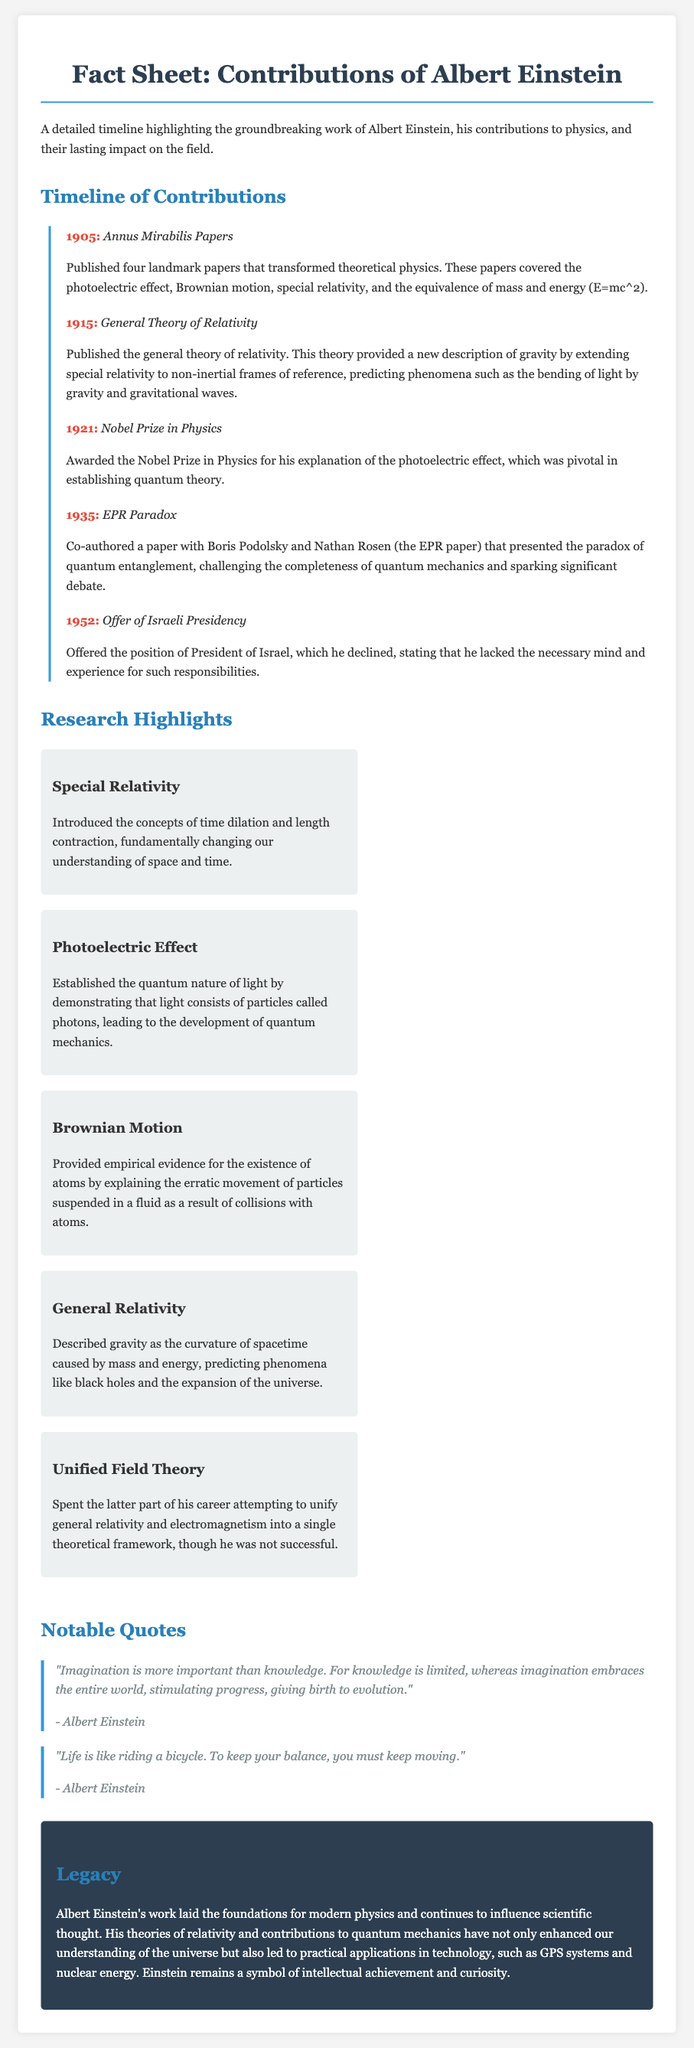What year did Einstein publish the Annus Mirabilis Papers? The Annus Mirabilis Papers were published in 1905, as stated in the timeline section.
Answer: 1905 What major theory did Einstein publish in 1915? The 1915 entry in the timeline mentions that Einstein published the general theory of relativity.
Answer: General Theory of Relativity For which contribution did Einstein win the Nobel Prize in 1921? According to the timeline, Einstein was awarded the Nobel Prize in Physics for his explanation of the photoelectric effect.
Answer: Photoelectric Effect What concept does Einstein's general relativity describe? The document states that general relativity describes gravity as the curvature of spacetime caused by mass and energy.
Answer: Curvature of spacetime What phenomenon did the EPR paper introduce? The EPR paper introduced the paradox of quantum entanglement, which is mentioned in the timeline.
Answer: Quantum entanglement What significant scientific concept was introduced in Einstein's special relativity? The document highlights that special relativity introduced the concepts of time dilation and length contraction.
Answer: Time dilation and length contraction What was Einstein's legacy according to the document? The legacy section outlines that Einstein's work laid the foundations for modern physics and influenced technological applications.
Answer: Foundations for modern physics Which work did Einstein attempt to unify in his later career? The document indicates Einstein spent his later career trying to unify general relativity and electromagnetism.
Answer: General relativity and electromagnetism 